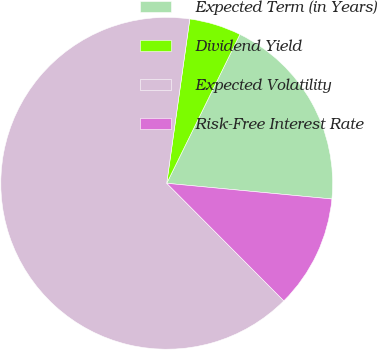<chart> <loc_0><loc_0><loc_500><loc_500><pie_chart><fcel>Expected Term (in Years)<fcel>Dividend Yield<fcel>Expected Volatility<fcel>Risk-Free Interest Rate<nl><fcel>19.24%<fcel>5.05%<fcel>64.7%<fcel>11.02%<nl></chart> 